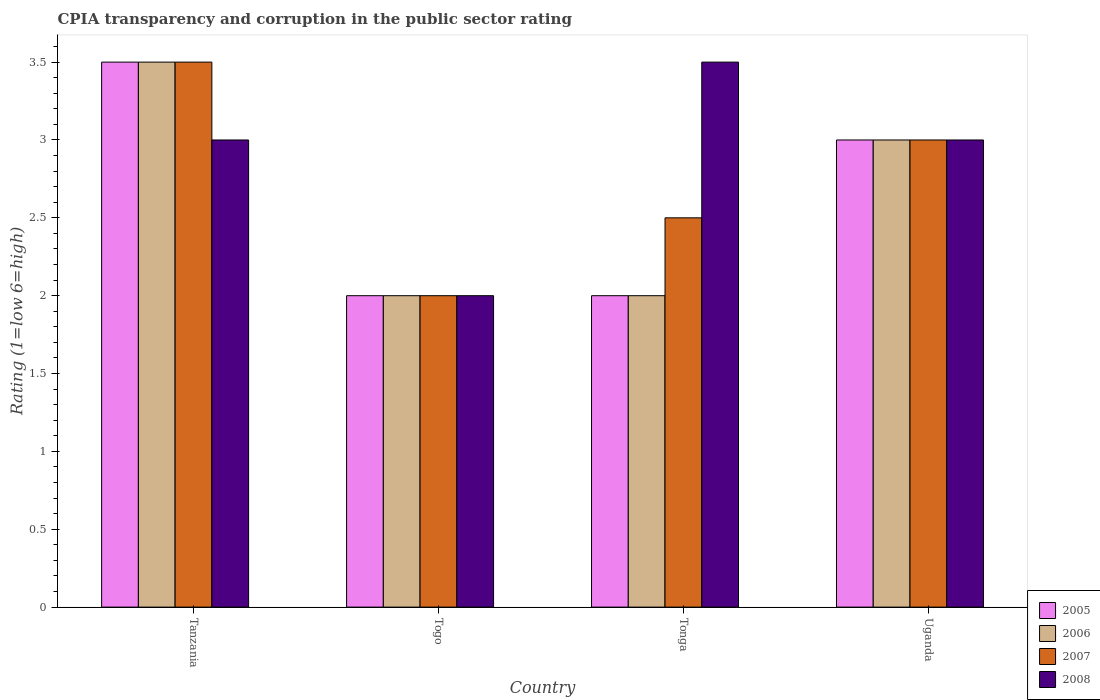How many different coloured bars are there?
Your response must be concise. 4. How many bars are there on the 4th tick from the right?
Your answer should be very brief. 4. What is the label of the 4th group of bars from the left?
Provide a short and direct response. Uganda. In how many cases, is the number of bars for a given country not equal to the number of legend labels?
Your answer should be very brief. 0. What is the CPIA rating in 2005 in Togo?
Your response must be concise. 2. Across all countries, what is the maximum CPIA rating in 2006?
Provide a short and direct response. 3.5. In which country was the CPIA rating in 2008 maximum?
Ensure brevity in your answer.  Tonga. In which country was the CPIA rating in 2008 minimum?
Provide a short and direct response. Togo. What is the difference between the CPIA rating in 2007 in Uganda and the CPIA rating in 2005 in Togo?
Provide a succinct answer. 1. What is the average CPIA rating in 2008 per country?
Offer a very short reply. 2.88. What is the difference between the CPIA rating of/in 2006 and CPIA rating of/in 2007 in Togo?
Provide a succinct answer. 0. In how many countries, is the CPIA rating in 2006 greater than 3.3?
Offer a very short reply. 1. What is the ratio of the CPIA rating in 2006 in Tanzania to that in Tonga?
Make the answer very short. 1.75. Is the difference between the CPIA rating in 2006 in Tanzania and Tonga greater than the difference between the CPIA rating in 2007 in Tanzania and Tonga?
Your answer should be compact. Yes. What is the difference between the highest and the second highest CPIA rating in 2008?
Offer a terse response. -0.5. In how many countries, is the CPIA rating in 2005 greater than the average CPIA rating in 2005 taken over all countries?
Your answer should be very brief. 2. Is the sum of the CPIA rating in 2007 in Tanzania and Uganda greater than the maximum CPIA rating in 2005 across all countries?
Provide a succinct answer. Yes. What does the 2nd bar from the right in Togo represents?
Give a very brief answer. 2007. Is it the case that in every country, the sum of the CPIA rating in 2006 and CPIA rating in 2005 is greater than the CPIA rating in 2007?
Ensure brevity in your answer.  Yes. Are the values on the major ticks of Y-axis written in scientific E-notation?
Your answer should be very brief. No. Where does the legend appear in the graph?
Offer a very short reply. Bottom right. What is the title of the graph?
Give a very brief answer. CPIA transparency and corruption in the public sector rating. What is the label or title of the X-axis?
Offer a terse response. Country. What is the Rating (1=low 6=high) in 2005 in Tanzania?
Offer a very short reply. 3.5. What is the Rating (1=low 6=high) of 2006 in Tanzania?
Ensure brevity in your answer.  3.5. What is the Rating (1=low 6=high) of 2007 in Tanzania?
Your answer should be compact. 3.5. What is the Rating (1=low 6=high) in 2008 in Tanzania?
Make the answer very short. 3. What is the Rating (1=low 6=high) in 2007 in Togo?
Provide a short and direct response. 2. What is the Rating (1=low 6=high) of 2008 in Togo?
Offer a very short reply. 2. What is the Rating (1=low 6=high) of 2006 in Tonga?
Provide a short and direct response. 2. What is the Rating (1=low 6=high) in 2006 in Uganda?
Your response must be concise. 3. What is the Rating (1=low 6=high) in 2007 in Uganda?
Give a very brief answer. 3. What is the Rating (1=low 6=high) in 2008 in Uganda?
Ensure brevity in your answer.  3. Across all countries, what is the maximum Rating (1=low 6=high) in 2005?
Provide a succinct answer. 3.5. Across all countries, what is the maximum Rating (1=low 6=high) of 2007?
Make the answer very short. 3.5. Across all countries, what is the minimum Rating (1=low 6=high) in 2005?
Offer a terse response. 2. Across all countries, what is the minimum Rating (1=low 6=high) in 2008?
Your answer should be very brief. 2. What is the total Rating (1=low 6=high) of 2006 in the graph?
Give a very brief answer. 10.5. What is the total Rating (1=low 6=high) in 2007 in the graph?
Provide a short and direct response. 11. What is the difference between the Rating (1=low 6=high) in 2006 in Tanzania and that in Uganda?
Your response must be concise. 0.5. What is the difference between the Rating (1=low 6=high) in 2007 in Tanzania and that in Uganda?
Offer a terse response. 0.5. What is the difference between the Rating (1=low 6=high) of 2008 in Tanzania and that in Uganda?
Offer a terse response. 0. What is the difference between the Rating (1=low 6=high) in 2005 in Togo and that in Uganda?
Offer a terse response. -1. What is the difference between the Rating (1=low 6=high) in 2006 in Togo and that in Uganda?
Provide a succinct answer. -1. What is the difference between the Rating (1=low 6=high) in 2008 in Togo and that in Uganda?
Your response must be concise. -1. What is the difference between the Rating (1=low 6=high) of 2008 in Tonga and that in Uganda?
Provide a succinct answer. 0.5. What is the difference between the Rating (1=low 6=high) of 2005 in Tanzania and the Rating (1=low 6=high) of 2008 in Togo?
Ensure brevity in your answer.  1.5. What is the difference between the Rating (1=low 6=high) in 2006 in Tanzania and the Rating (1=low 6=high) in 2007 in Togo?
Provide a succinct answer. 1.5. What is the difference between the Rating (1=low 6=high) of 2005 in Tanzania and the Rating (1=low 6=high) of 2006 in Tonga?
Your response must be concise. 1.5. What is the difference between the Rating (1=low 6=high) in 2005 in Tanzania and the Rating (1=low 6=high) in 2006 in Uganda?
Your answer should be compact. 0.5. What is the difference between the Rating (1=low 6=high) of 2005 in Tanzania and the Rating (1=low 6=high) of 2007 in Uganda?
Your answer should be very brief. 0.5. What is the difference between the Rating (1=low 6=high) of 2005 in Tanzania and the Rating (1=low 6=high) of 2008 in Uganda?
Make the answer very short. 0.5. What is the difference between the Rating (1=low 6=high) in 2006 in Tanzania and the Rating (1=low 6=high) in 2007 in Uganda?
Ensure brevity in your answer.  0.5. What is the difference between the Rating (1=low 6=high) in 2006 in Togo and the Rating (1=low 6=high) in 2008 in Tonga?
Your answer should be compact. -1.5. What is the difference between the Rating (1=low 6=high) in 2007 in Togo and the Rating (1=low 6=high) in 2008 in Tonga?
Give a very brief answer. -1.5. What is the difference between the Rating (1=low 6=high) of 2005 in Togo and the Rating (1=low 6=high) of 2007 in Uganda?
Your answer should be very brief. -1. What is the difference between the Rating (1=low 6=high) of 2006 in Togo and the Rating (1=low 6=high) of 2007 in Uganda?
Give a very brief answer. -1. What is the difference between the Rating (1=low 6=high) in 2005 in Tonga and the Rating (1=low 6=high) in 2006 in Uganda?
Offer a very short reply. -1. What is the difference between the Rating (1=low 6=high) in 2005 in Tonga and the Rating (1=low 6=high) in 2007 in Uganda?
Offer a very short reply. -1. What is the difference between the Rating (1=low 6=high) of 2005 in Tonga and the Rating (1=low 6=high) of 2008 in Uganda?
Offer a terse response. -1. What is the difference between the Rating (1=low 6=high) in 2006 in Tonga and the Rating (1=low 6=high) in 2007 in Uganda?
Ensure brevity in your answer.  -1. What is the difference between the Rating (1=low 6=high) in 2006 in Tonga and the Rating (1=low 6=high) in 2008 in Uganda?
Provide a short and direct response. -1. What is the difference between the Rating (1=low 6=high) of 2007 in Tonga and the Rating (1=low 6=high) of 2008 in Uganda?
Keep it short and to the point. -0.5. What is the average Rating (1=low 6=high) in 2005 per country?
Give a very brief answer. 2.62. What is the average Rating (1=low 6=high) of 2006 per country?
Provide a short and direct response. 2.62. What is the average Rating (1=low 6=high) in 2007 per country?
Your answer should be very brief. 2.75. What is the average Rating (1=low 6=high) in 2008 per country?
Keep it short and to the point. 2.88. What is the difference between the Rating (1=low 6=high) of 2005 and Rating (1=low 6=high) of 2007 in Tanzania?
Ensure brevity in your answer.  0. What is the difference between the Rating (1=low 6=high) in 2005 and Rating (1=low 6=high) in 2008 in Tanzania?
Provide a succinct answer. 0.5. What is the difference between the Rating (1=low 6=high) in 2006 and Rating (1=low 6=high) in 2008 in Tanzania?
Provide a succinct answer. 0.5. What is the difference between the Rating (1=low 6=high) of 2005 and Rating (1=low 6=high) of 2006 in Togo?
Offer a terse response. 0. What is the difference between the Rating (1=low 6=high) of 2006 and Rating (1=low 6=high) of 2007 in Togo?
Your answer should be compact. 0. What is the difference between the Rating (1=low 6=high) of 2006 and Rating (1=low 6=high) of 2008 in Togo?
Keep it short and to the point. 0. What is the difference between the Rating (1=low 6=high) of 2005 and Rating (1=low 6=high) of 2006 in Tonga?
Offer a very short reply. 0. What is the difference between the Rating (1=low 6=high) of 2005 and Rating (1=low 6=high) of 2007 in Tonga?
Ensure brevity in your answer.  -0.5. What is the difference between the Rating (1=low 6=high) of 2005 and Rating (1=low 6=high) of 2008 in Tonga?
Make the answer very short. -1.5. What is the difference between the Rating (1=low 6=high) in 2006 and Rating (1=low 6=high) in 2008 in Tonga?
Ensure brevity in your answer.  -1.5. What is the difference between the Rating (1=low 6=high) in 2005 and Rating (1=low 6=high) in 2008 in Uganda?
Provide a short and direct response. 0. What is the difference between the Rating (1=low 6=high) in 2006 and Rating (1=low 6=high) in 2007 in Uganda?
Ensure brevity in your answer.  0. What is the difference between the Rating (1=low 6=high) of 2007 and Rating (1=low 6=high) of 2008 in Uganda?
Your answer should be very brief. 0. What is the ratio of the Rating (1=low 6=high) of 2005 in Tanzania to that in Togo?
Your answer should be compact. 1.75. What is the ratio of the Rating (1=low 6=high) in 2007 in Tanzania to that in Togo?
Provide a succinct answer. 1.75. What is the ratio of the Rating (1=low 6=high) of 2008 in Tanzania to that in Togo?
Your answer should be very brief. 1.5. What is the ratio of the Rating (1=low 6=high) of 2005 in Tanzania to that in Uganda?
Your answer should be compact. 1.17. What is the ratio of the Rating (1=low 6=high) in 2006 in Tanzania to that in Uganda?
Offer a very short reply. 1.17. What is the ratio of the Rating (1=low 6=high) in 2007 in Tanzania to that in Uganda?
Offer a terse response. 1.17. What is the ratio of the Rating (1=low 6=high) in 2008 in Tanzania to that in Uganda?
Keep it short and to the point. 1. What is the ratio of the Rating (1=low 6=high) in 2007 in Togo to that in Tonga?
Offer a terse response. 0.8. What is the ratio of the Rating (1=low 6=high) of 2008 in Togo to that in Tonga?
Provide a succinct answer. 0.57. What is the ratio of the Rating (1=low 6=high) of 2006 in Togo to that in Uganda?
Your answer should be very brief. 0.67. What is the ratio of the Rating (1=low 6=high) in 2008 in Tonga to that in Uganda?
Your response must be concise. 1.17. What is the difference between the highest and the second highest Rating (1=low 6=high) in 2005?
Your answer should be compact. 0.5. What is the difference between the highest and the second highest Rating (1=low 6=high) of 2007?
Offer a terse response. 0.5. What is the difference between the highest and the second highest Rating (1=low 6=high) in 2008?
Provide a succinct answer. 0.5. What is the difference between the highest and the lowest Rating (1=low 6=high) of 2006?
Make the answer very short. 1.5. 